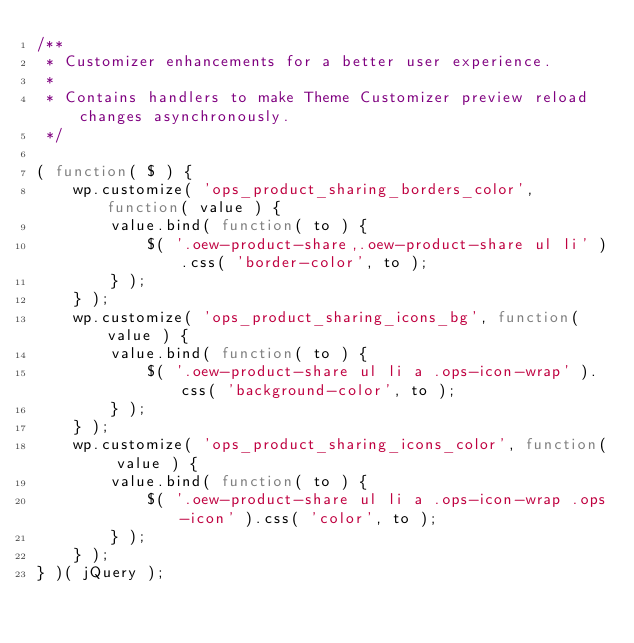<code> <loc_0><loc_0><loc_500><loc_500><_JavaScript_>/**
 * Customizer enhancements for a better user experience.
 *
 * Contains handlers to make Theme Customizer preview reload changes asynchronously.
 */

( function( $ ) {
	wp.customize( 'ops_product_sharing_borders_color', function( value ) {
		value.bind( function( to ) {
			$( '.oew-product-share,.oew-product-share ul li' ).css( 'border-color', to );
		} );
	} );
	wp.customize( 'ops_product_sharing_icons_bg', function( value ) {
		value.bind( function( to ) {
			$( '.oew-product-share ul li a .ops-icon-wrap' ).css( 'background-color', to );
		} );
	} );
	wp.customize( 'ops_product_sharing_icons_color', function( value ) {
		value.bind( function( to ) {
			$( '.oew-product-share ul li a .ops-icon-wrap .ops-icon' ).css( 'color', to );
		} );
	} );
} )( jQuery );
</code> 